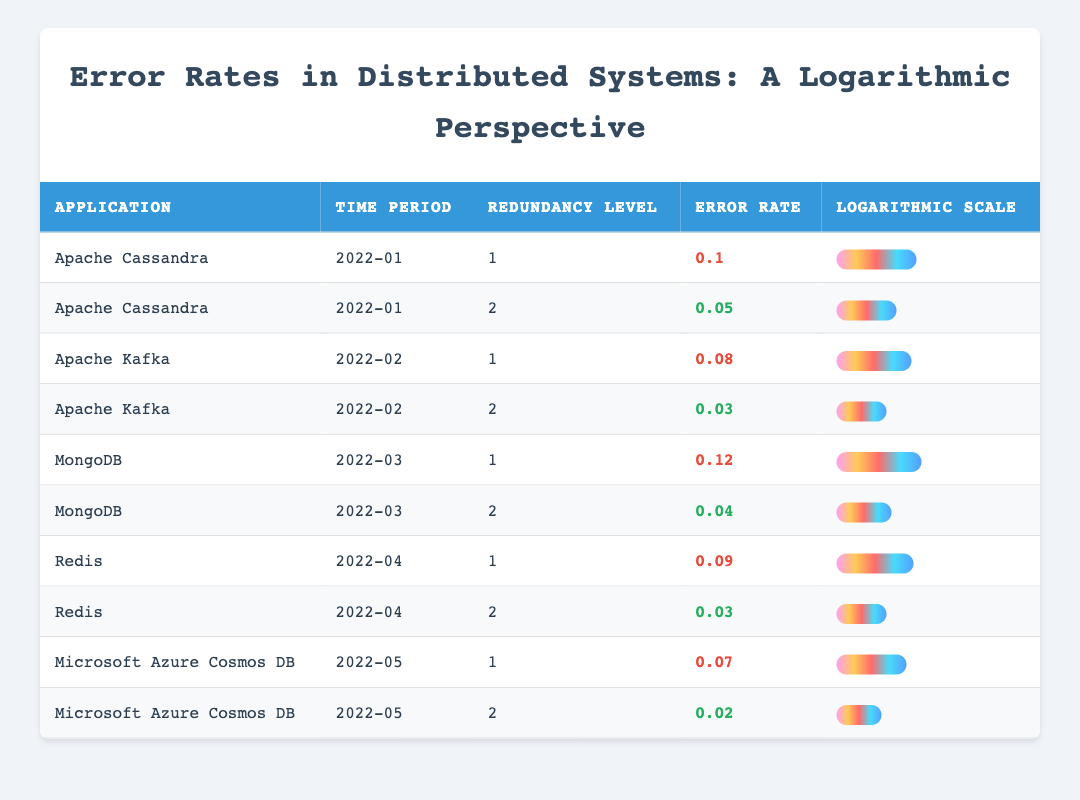What is the error rate of Apache Kafka with redundancy level 1 in February 2022? The table lists the error rates of various applications in different time periods. By locating the entry for Apache Kafka with redundancy level 1 and the time period of February 2022, we see that the error rate is 0.08.
Answer: 0.08 What is the error rate of Microsoft Azure Cosmos DB with redundancy level 2 in May 2022? Looking at the table, we find the row for Microsoft Azure Cosmos DB with redundancy level 2 for May 2022, which indicates an error rate of 0.02.
Answer: 0.02 Which application has the lowest error rate recorded with redundancy level 2? To determine the application with the lowest error rate for redundancy level 2, we look at all entries for redundancy level 2: Apache Cassandra (0.05), Apache Kafka (0.03), MongoDB (0.04), Redis (0.03), and Microsoft Azure Cosmos DB (0.02). The lowest among these is for Microsoft Azure Cosmos DB at 0.02.
Answer: Microsoft Azure Cosmos DB What is the difference in error rate between redundancy level 1 and level 2 for MongoDB? The error rate for MongoDB with redundancy level 1 is 0.12 and with redundancy level 2 is 0.04. To find the difference, we subtract the error rate of redundancy level 2 from that of level 1: 0.12 - 0.04 = 0.08.
Answer: 0.08 Is there an application with redundancy level 1 that has a higher error rate than 0.1? We check the entries for redundancy level 1 and find the following error rates: Apache Cassandra (0.1), Apache Kafka (0.08), MongoDB (0.12), Redis (0.09), and Microsoft Azure Cosmos DB (0.07). The only application with redundancy level 1 that has a higher error rate than 0.1 is MongoDB (0.12).
Answer: Yes What is the average error rate of applications with redundancy level 2? We find the error rates for redundancy level 2: Apache Cassandra (0.05), Apache Kafka (0.03), MongoDB (0.04), Redis (0.03), and Microsoft Azure Cosmos DB (0.02). To find the average, we sum these amounts: 0.05 + 0.03 + 0.04 + 0.03 + 0.02 = 0.17. Then, we divide by the number of entries, which is 5: 0.17 / 5 = 0.034.
Answer: 0.034 Which application shows the most improvement in error rates when comparing redundancy levels 1 and 2? We analyze the error rates: Apache Cassandra shows a decrease from 0.1 to 0.05 (0.05 improvement), Apache Kafka from 0.08 to 0.03 (0.05 improvement), MongoDB from 0.12 to 0.04 (0.08 improvement), Redis from 0.09 to 0.03 (0.06 improvement), and Microsoft Azure Cosmos DB from 0.07 to 0.02 (0.05 improvement). MongoDB shows the most improvement, reducing its error rate by 0.08.
Answer: MongoDB What were the error rates for Apache Cassandra across both redundancy levels in January 2022? In the table, the error rates for Apache Cassandra in January 2022 are 0.1 for redundancy level 1, and 0.05 for redundancy level 2. We can summarize this by stating the two values together.
Answer: 0.1 and 0.05 